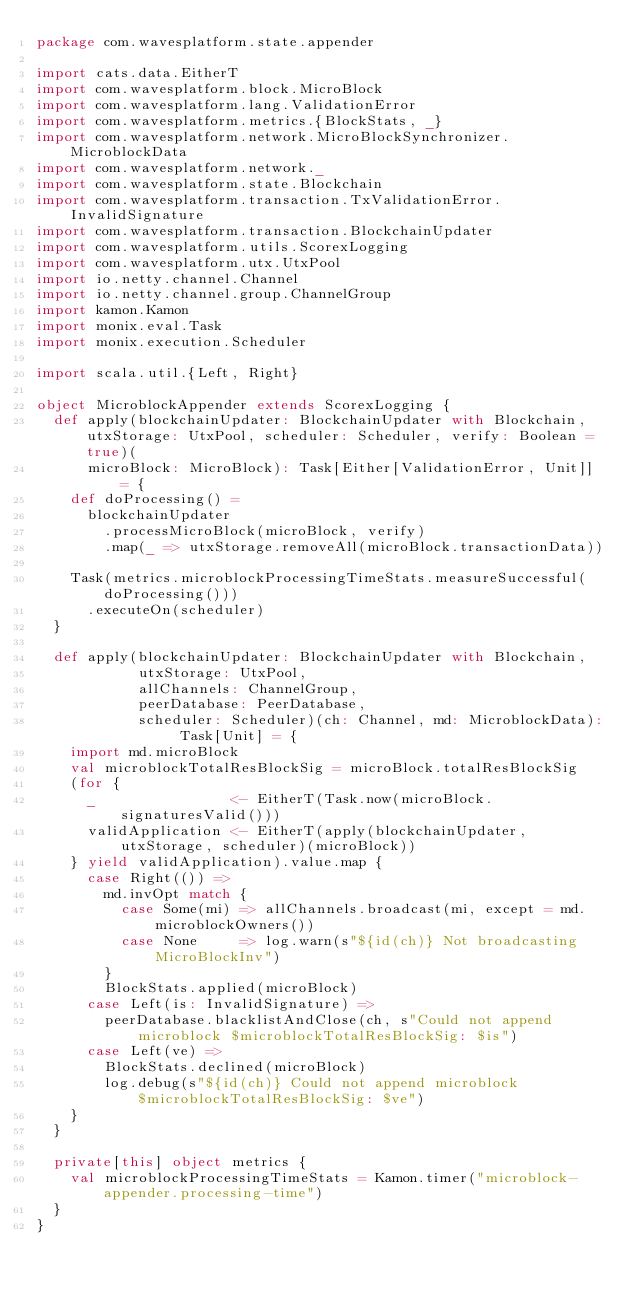<code> <loc_0><loc_0><loc_500><loc_500><_Scala_>package com.wavesplatform.state.appender

import cats.data.EitherT
import com.wavesplatform.block.MicroBlock
import com.wavesplatform.lang.ValidationError
import com.wavesplatform.metrics.{BlockStats, _}
import com.wavesplatform.network.MicroBlockSynchronizer.MicroblockData
import com.wavesplatform.network._
import com.wavesplatform.state.Blockchain
import com.wavesplatform.transaction.TxValidationError.InvalidSignature
import com.wavesplatform.transaction.BlockchainUpdater
import com.wavesplatform.utils.ScorexLogging
import com.wavesplatform.utx.UtxPool
import io.netty.channel.Channel
import io.netty.channel.group.ChannelGroup
import kamon.Kamon
import monix.eval.Task
import monix.execution.Scheduler

import scala.util.{Left, Right}

object MicroblockAppender extends ScorexLogging {
  def apply(blockchainUpdater: BlockchainUpdater with Blockchain, utxStorage: UtxPool, scheduler: Scheduler, verify: Boolean = true)(
      microBlock: MicroBlock): Task[Either[ValidationError, Unit]] = {
    def doProcessing() =
      blockchainUpdater
        .processMicroBlock(microBlock, verify)
        .map(_ => utxStorage.removeAll(microBlock.transactionData))

    Task(metrics.microblockProcessingTimeStats.measureSuccessful(doProcessing()))
      .executeOn(scheduler)
  }

  def apply(blockchainUpdater: BlockchainUpdater with Blockchain,
            utxStorage: UtxPool,
            allChannels: ChannelGroup,
            peerDatabase: PeerDatabase,
            scheduler: Scheduler)(ch: Channel, md: MicroblockData): Task[Unit] = {
    import md.microBlock
    val microblockTotalResBlockSig = microBlock.totalResBlockSig
    (for {
      _                <- EitherT(Task.now(microBlock.signaturesValid()))
      validApplication <- EitherT(apply(blockchainUpdater, utxStorage, scheduler)(microBlock))
    } yield validApplication).value.map {
      case Right(()) =>
        md.invOpt match {
          case Some(mi) => allChannels.broadcast(mi, except = md.microblockOwners())
          case None     => log.warn(s"${id(ch)} Not broadcasting MicroBlockInv")
        }
        BlockStats.applied(microBlock)
      case Left(is: InvalidSignature) =>
        peerDatabase.blacklistAndClose(ch, s"Could not append microblock $microblockTotalResBlockSig: $is")
      case Left(ve) =>
        BlockStats.declined(microBlock)
        log.debug(s"${id(ch)} Could not append microblock $microblockTotalResBlockSig: $ve")
    }
  }

  private[this] object metrics {
    val microblockProcessingTimeStats = Kamon.timer("microblock-appender.processing-time")
  }
}
</code> 